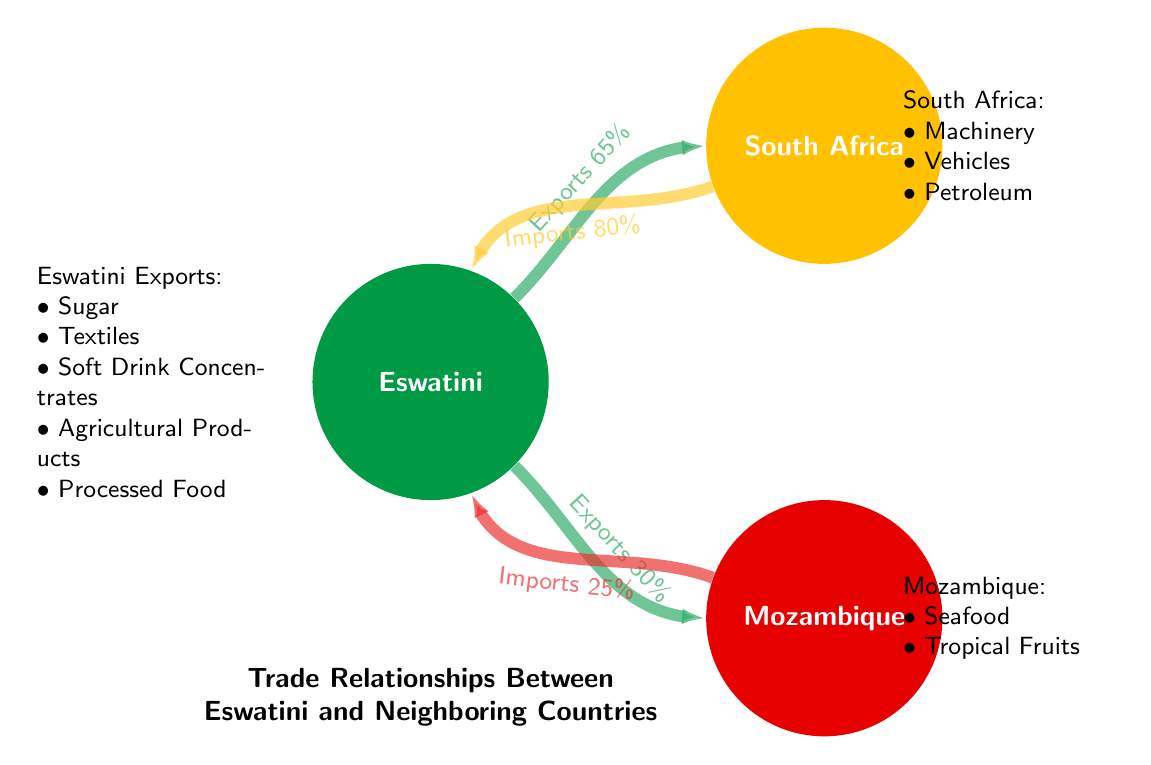What percentage of exports does Eswatini send to South Africa? The diagram states that Eswatini exports 65% of its products to South Africa. This percentage is clearly indicated along the flow from Eswatini to South Africa.
Answer: 65% What are the main products Eswatini exports to South Africa? The diagram specifies multiple products that Eswatini exports to South Africa. These products are listed as Sugar, Textiles, and Soft Drink Concentrates next to the arrow indicating exports.
Answer: Sugar, Textiles, Soft Drink Concentrates How much does Eswatini import from Mozambique? The imports from Mozambique to Eswatini are indicated in the diagram as 25%. This is shown along the flow from Mozambique to Eswatini.
Answer: 25% How do the exports of Eswatini to South Africa compare to its exports to Mozambique? The diagram shows that Eswatini exports 65% to South Africa and 30% to Mozambique. By comparison, the exports to South Africa are higher than those to Mozambique, indicating that South Africa is a key trading partner for Eswatini.
Answer: Higher What is the total value of imports Eswatini receives from South Africa and Mozambique? The diagram indicates that Eswatini imports 80% from South Africa and 25% from Mozambique. To find the total, we simply add these two values: 80% + 25% = 105%. Therefore, the total imports from these two countries combined is 105%.
Answer: 105% Which country has the highest trade flow with Eswatini? By examining the flows, it is evident that the trade flow from South Africa to Eswatini is 80%, which is higher than any trade flow coming from Mozambique or going to South Africa. Therefore, South Africa has the highest trade flow with Eswatini.
Answer: South Africa What are the main products that Eswatini imports from South Africa? The diagram lists Machinery, Vehicles, and Petroleum as the main products Eswatini imports from South Africa. These products are detailed next to the arrow indicating imports.
Answer: Machinery, Vehicles, Petroleum What is the total number of nodes in this diagram? The diagram features three nodes: Eswatini, South Africa, and Mozambique. Counting these distinct locations gives us the total number of nodes.
Answer: 3 What type of diagram is being used to represent trade relationships? The visual representation of trade relationships in this data is identified as a Chord Diagram, which specifically showcases the connections and flow between the nodes in a circular arrangement.
Answer: Chord Diagram 